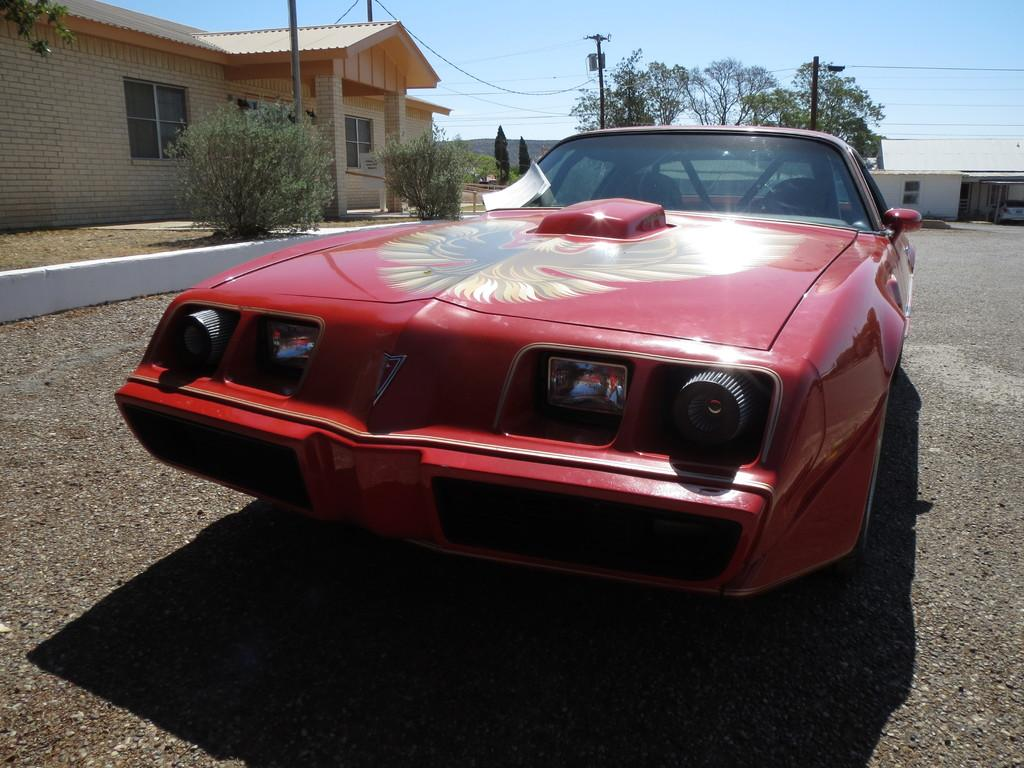What color is the car in the picture? The car in the picture is red. What is located on the left side of the picture? There is a house on the left side of the picture. What type of vegetation can be seen in the picture? There are trees in the picture. What is the tall, vertical object in the picture? There is a pole in the picture. picture. What is visible at the top of the picture? The sky is visible at the top of the picture. Can you hear the ice melting in the picture? There is no ice present in the picture, so it is not possible to hear it melting. 